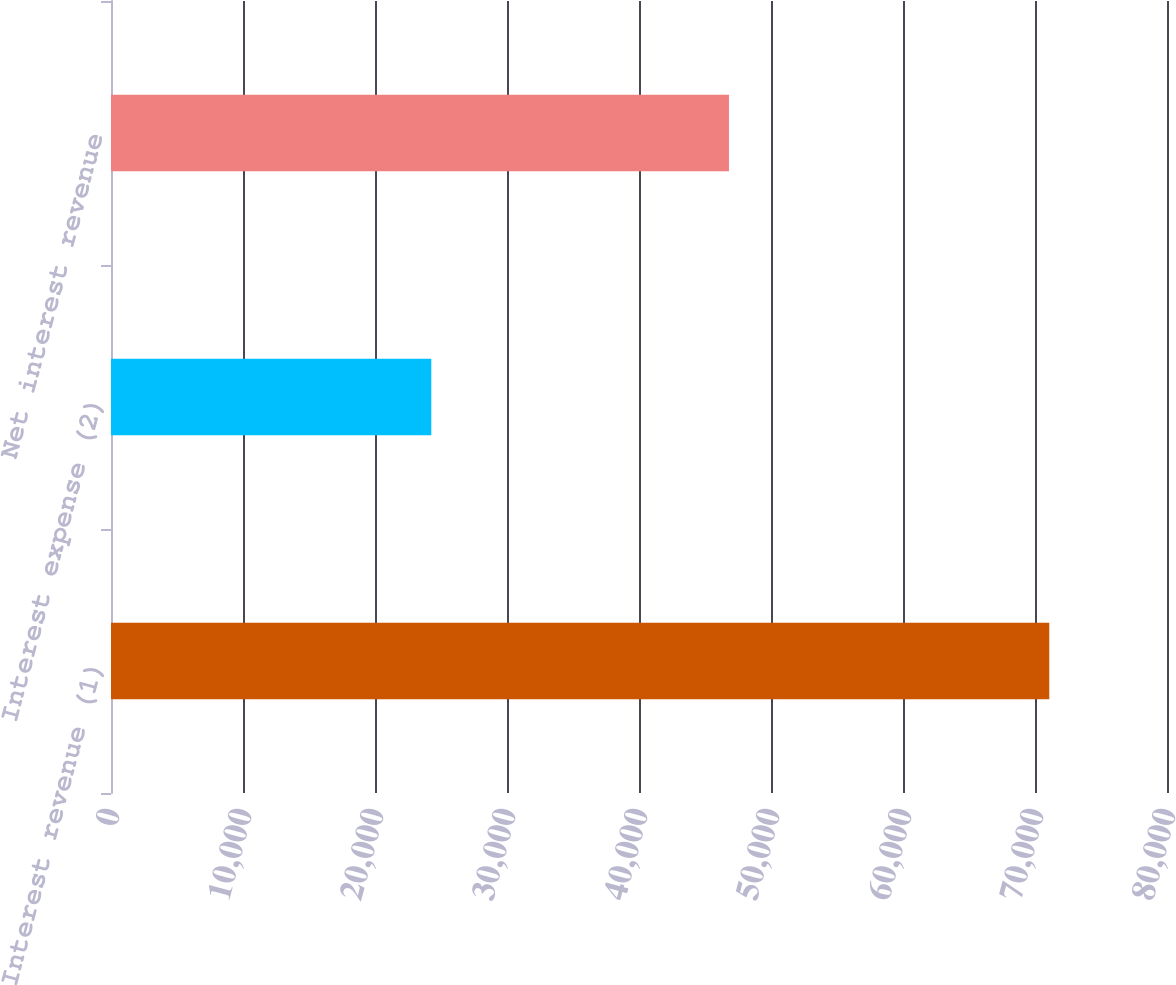Convert chart. <chart><loc_0><loc_0><loc_500><loc_500><bar_chart><fcel>Interest revenue (1)<fcel>Interest expense (2)<fcel>Net interest revenue<nl><fcel>71082<fcel>24266<fcel>46816<nl></chart> 